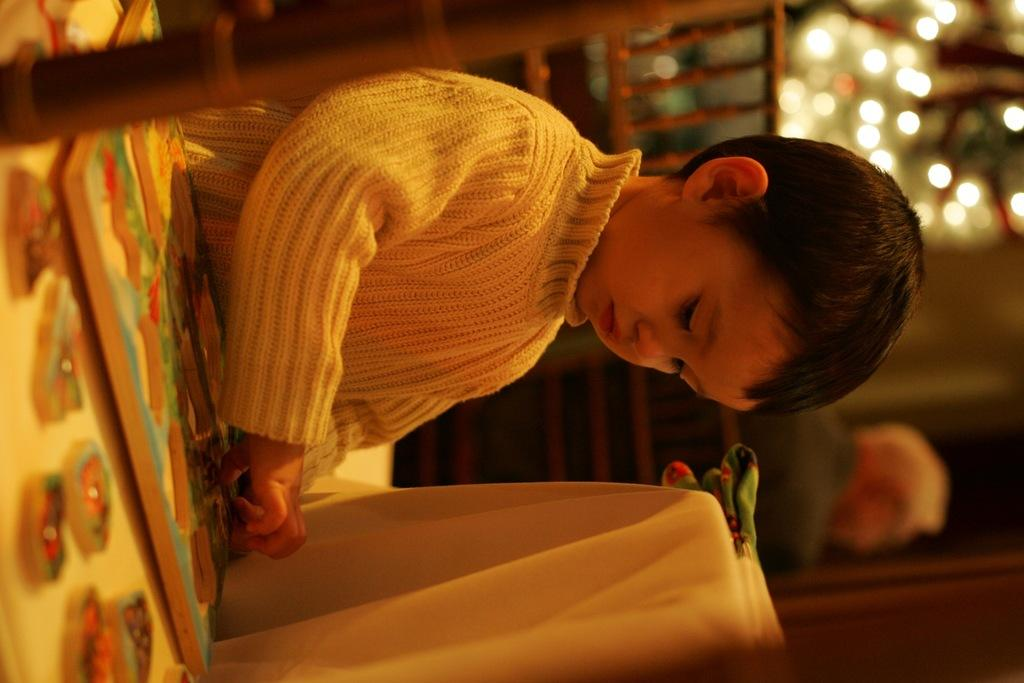What is the main subject of the image? The main subject of the image is a kid. Can you describe the background of the image? In the background of the image, there are lights visible. What type of powder is the kid using in the image? There is no powder present in the image; the main subject is a kid, and the background features lights. 